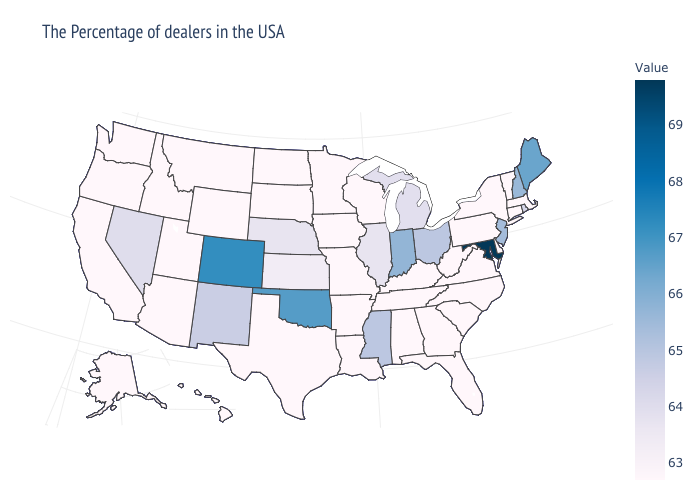Among the states that border Nebraska , does South Dakota have the lowest value?
Give a very brief answer. Yes. Does Arkansas have a higher value than Michigan?
Be succinct. No. Does Missouri have the highest value in the MidWest?
Write a very short answer. No. Which states have the lowest value in the MidWest?
Quick response, please. Wisconsin, Missouri, Minnesota, Iowa, South Dakota, North Dakota. 